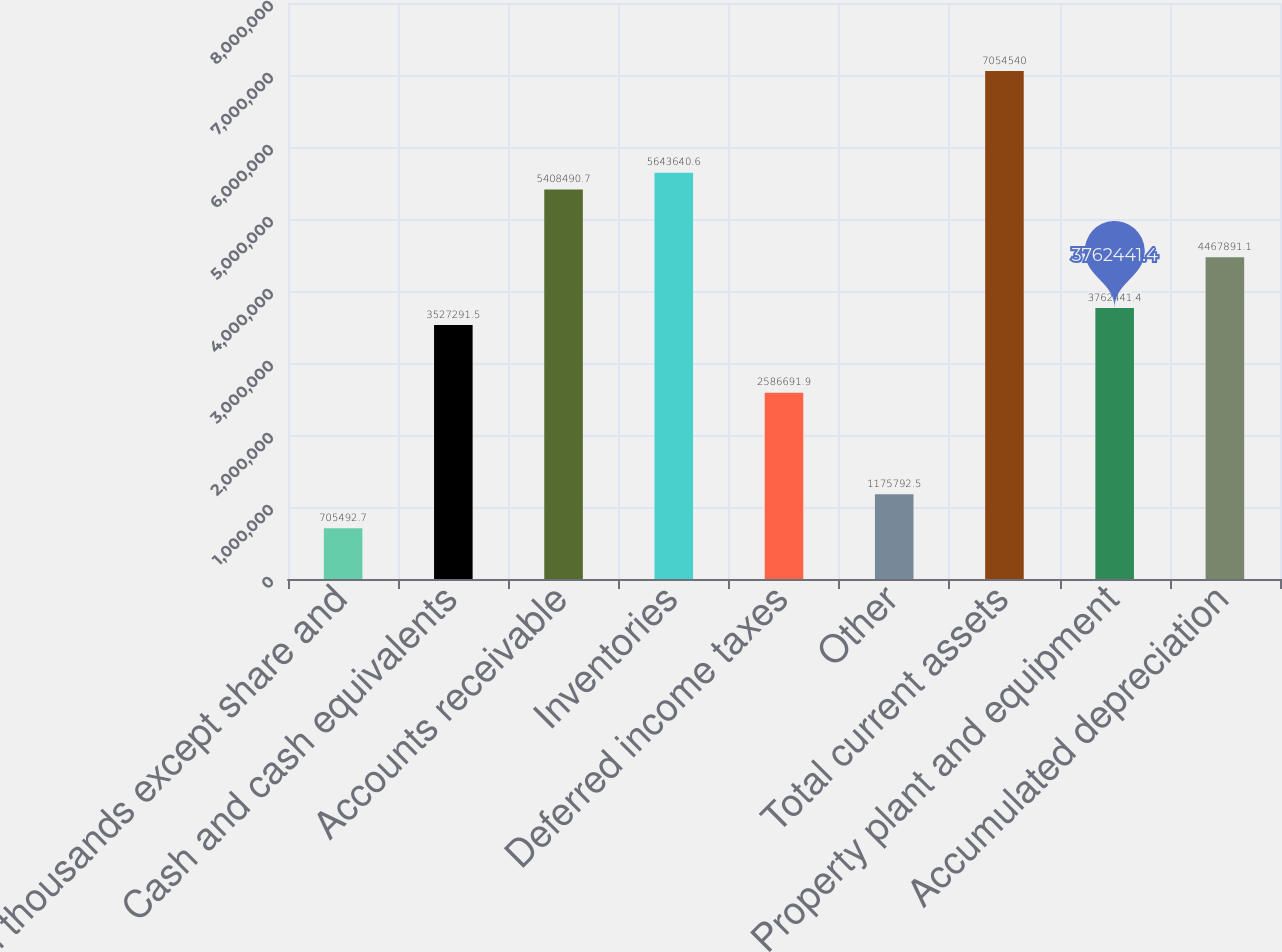<chart> <loc_0><loc_0><loc_500><loc_500><bar_chart><fcel>In thousands except share and<fcel>Cash and cash equivalents<fcel>Accounts receivable<fcel>Inventories<fcel>Deferred income taxes<fcel>Other<fcel>Total current assets<fcel>Property plant and equipment<fcel>Accumulated depreciation<nl><fcel>705493<fcel>3.52729e+06<fcel>5.40849e+06<fcel>5.64364e+06<fcel>2.58669e+06<fcel>1.17579e+06<fcel>7.05454e+06<fcel>3.76244e+06<fcel>4.46789e+06<nl></chart> 